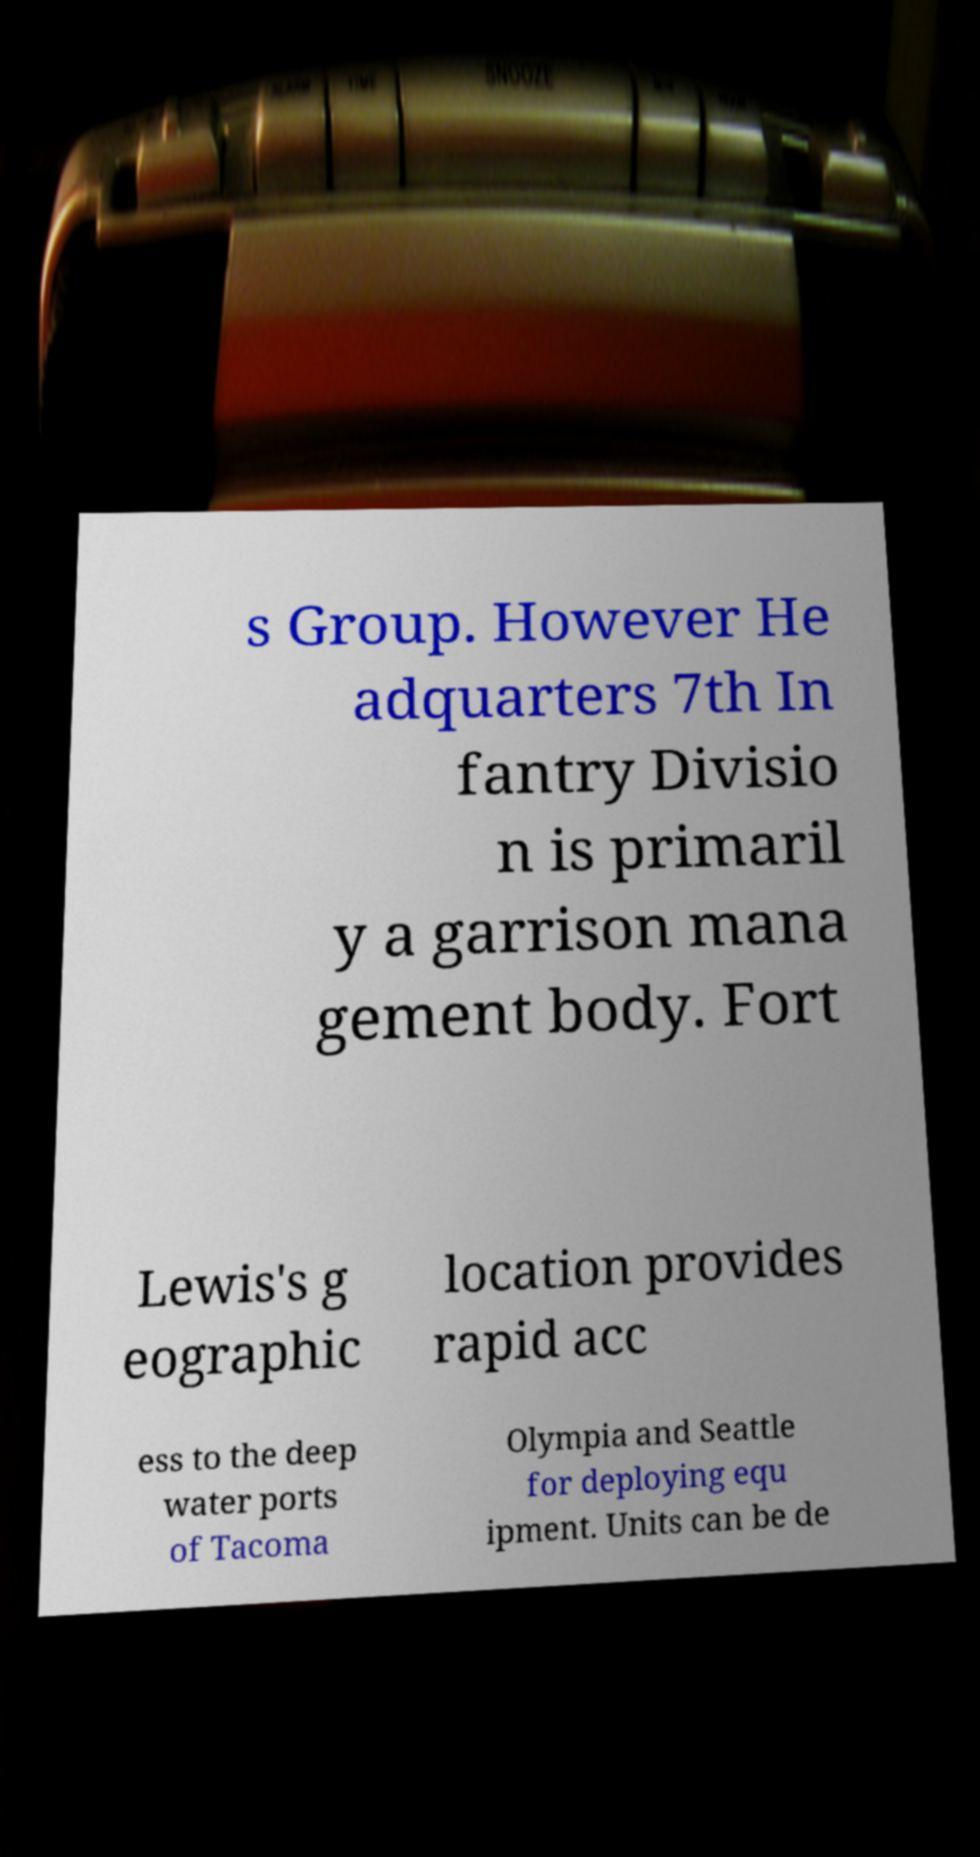I need the written content from this picture converted into text. Can you do that? s Group. However He adquarters 7th In fantry Divisio n is primaril y a garrison mana gement body. Fort Lewis's g eographic location provides rapid acc ess to the deep water ports of Tacoma Olympia and Seattle for deploying equ ipment. Units can be de 